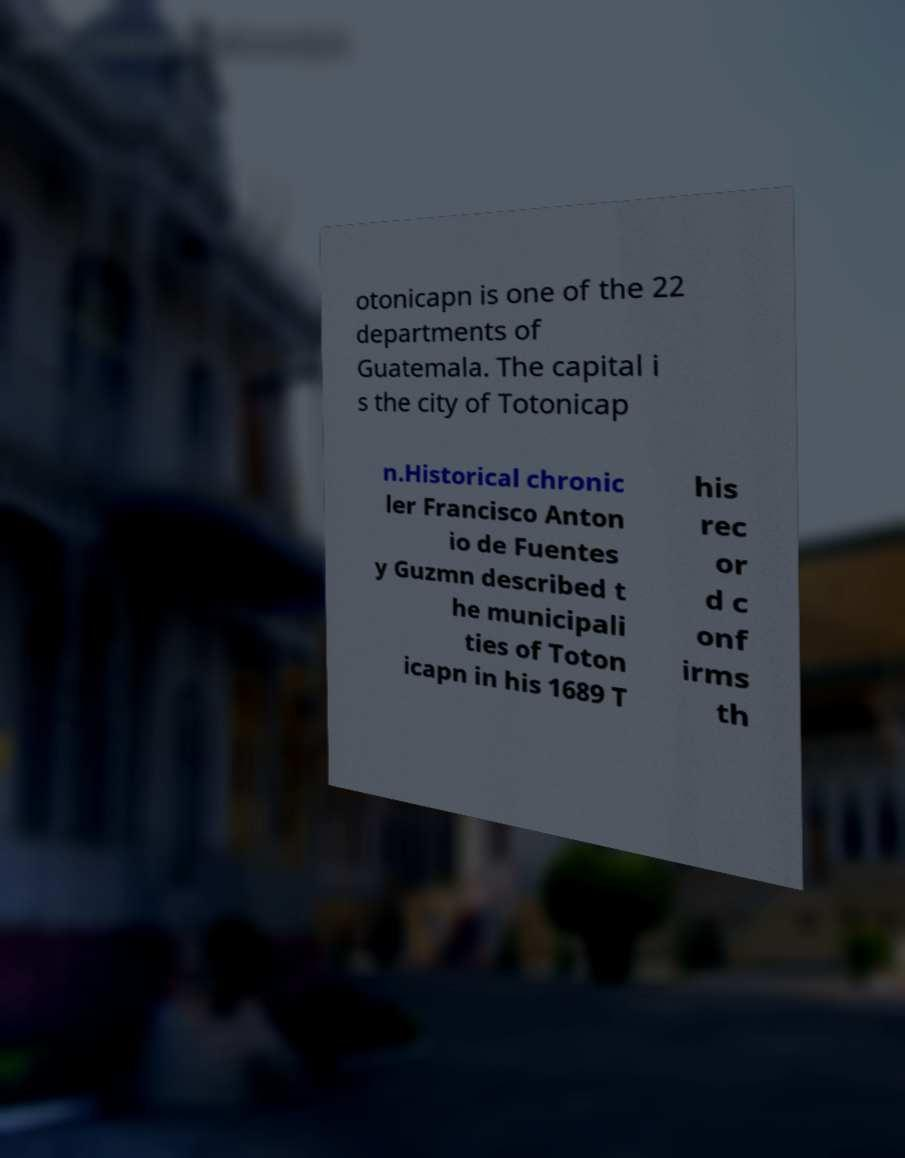Please identify and transcribe the text found in this image. otonicapn is one of the 22 departments of Guatemala. The capital i s the city of Totonicap n.Historical chronic ler Francisco Anton io de Fuentes y Guzmn described t he municipali ties of Toton icapn in his 1689 T his rec or d c onf irms th 